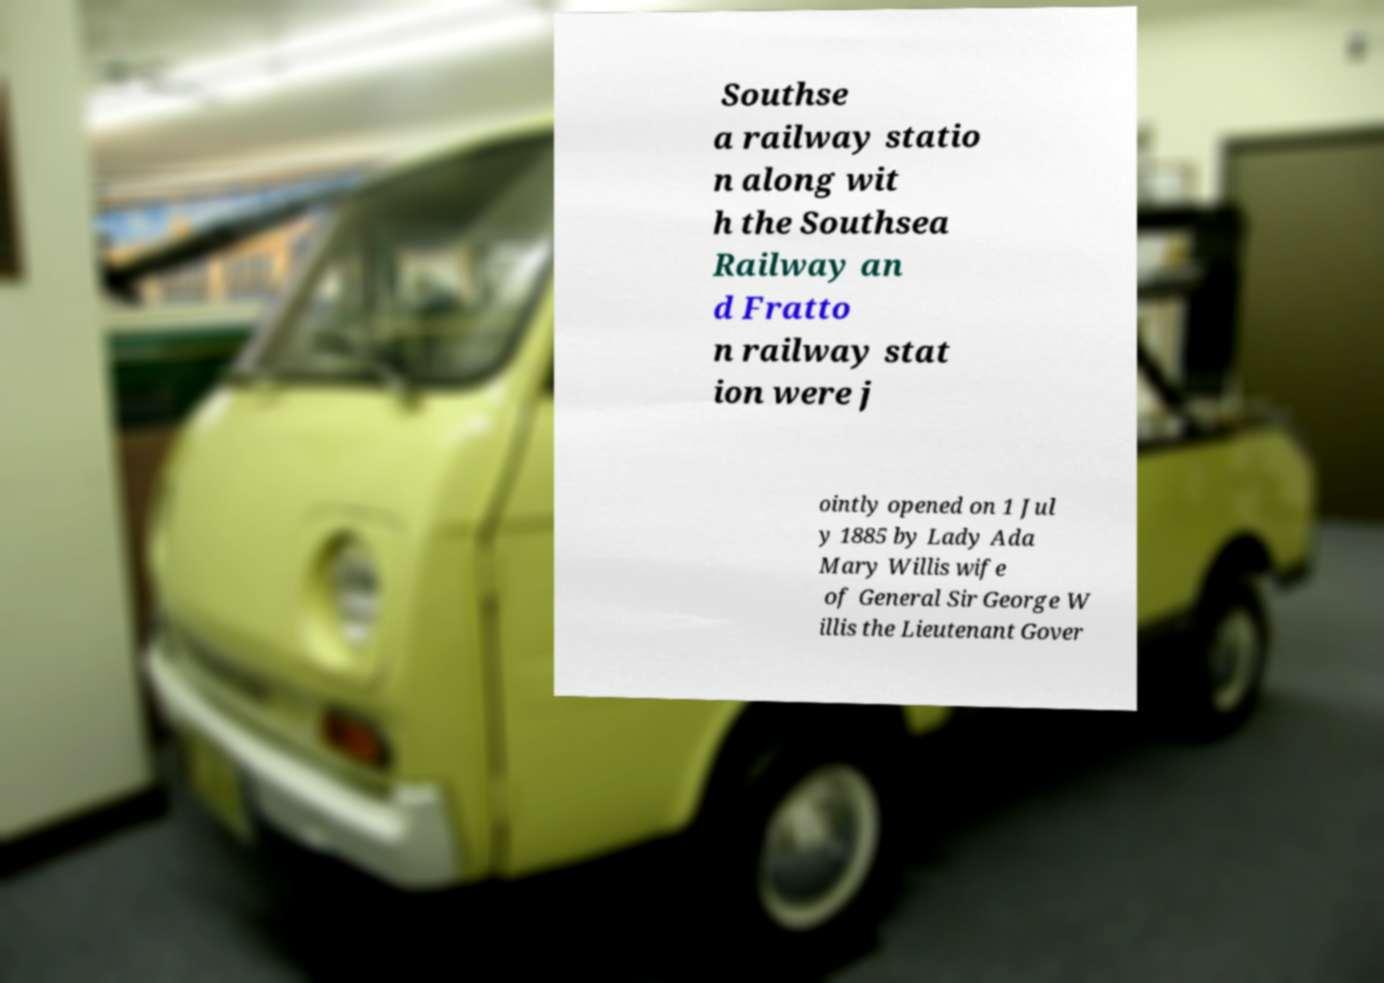Can you accurately transcribe the text from the provided image for me? Southse a railway statio n along wit h the Southsea Railway an d Fratto n railway stat ion were j ointly opened on 1 Jul y 1885 by Lady Ada Mary Willis wife of General Sir George W illis the Lieutenant Gover 